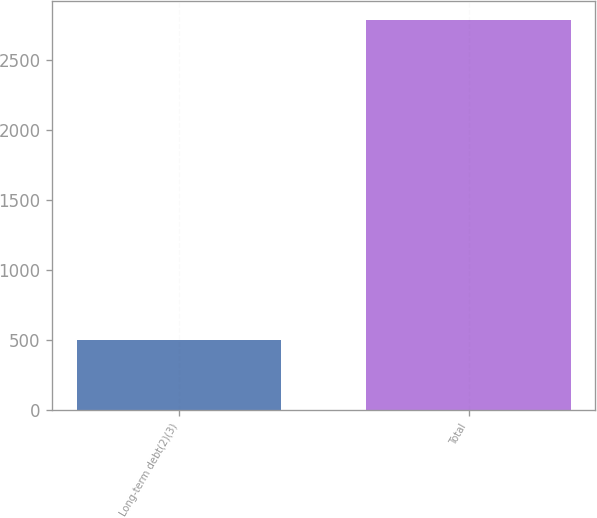<chart> <loc_0><loc_0><loc_500><loc_500><bar_chart><fcel>Long-term debt(2)(3)<fcel>Total<nl><fcel>500<fcel>2783<nl></chart> 